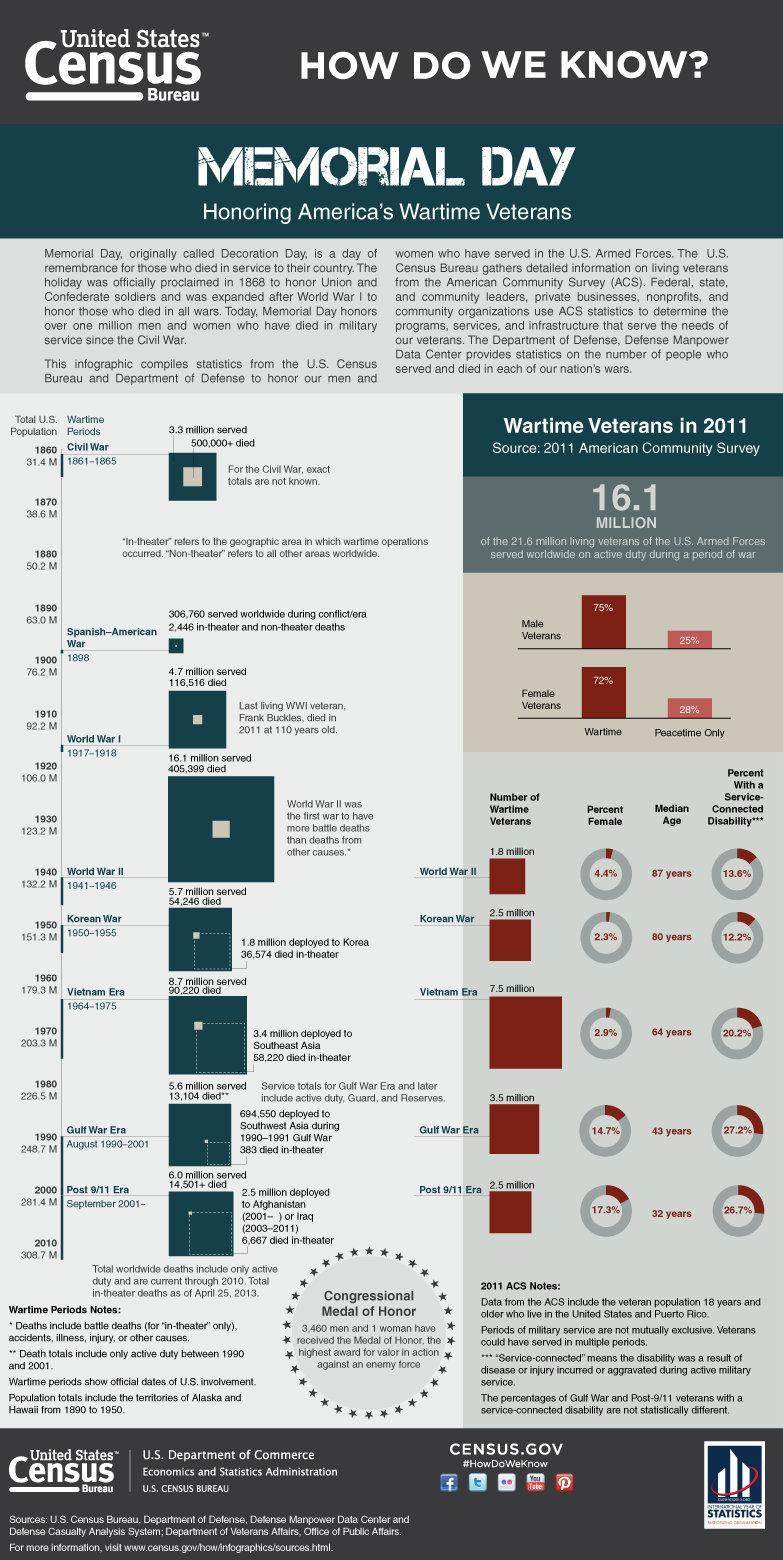How many men have received the Medal of Honor?
Answer the question with a short phrase. 3,460 What is the percentage of females in World War II veterans? 4.4% 